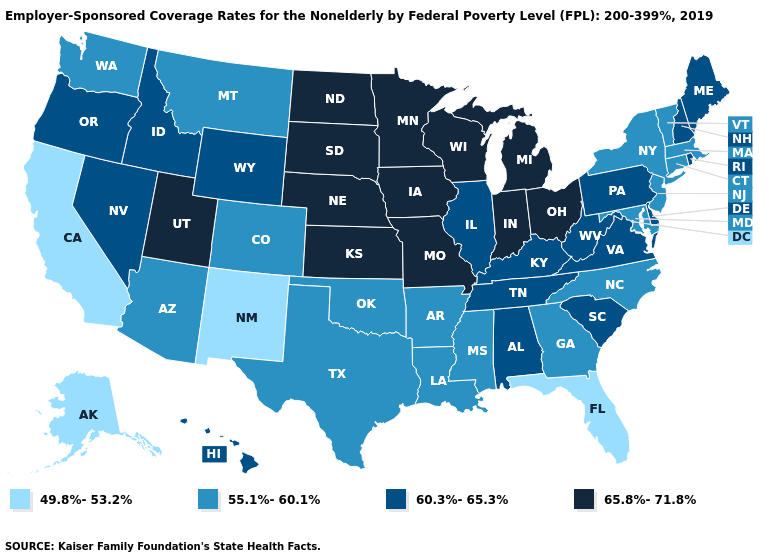Which states have the lowest value in the USA?
Concise answer only. Alaska, California, Florida, New Mexico. What is the lowest value in the USA?
Be succinct. 49.8%-53.2%. Name the states that have a value in the range 49.8%-53.2%?
Answer briefly. Alaska, California, Florida, New Mexico. Does Maine have a higher value than Wyoming?
Give a very brief answer. No. What is the value of Louisiana?
Be succinct. 55.1%-60.1%. Does Kansas have a higher value than North Dakota?
Be succinct. No. What is the lowest value in the USA?
Answer briefly. 49.8%-53.2%. Name the states that have a value in the range 55.1%-60.1%?
Answer briefly. Arizona, Arkansas, Colorado, Connecticut, Georgia, Louisiana, Maryland, Massachusetts, Mississippi, Montana, New Jersey, New York, North Carolina, Oklahoma, Texas, Vermont, Washington. What is the value of Texas?
Keep it brief. 55.1%-60.1%. Among the states that border Oklahoma , which have the lowest value?
Answer briefly. New Mexico. Does the map have missing data?
Keep it brief. No. What is the value of Michigan?
Short answer required. 65.8%-71.8%. Does North Dakota have the highest value in the USA?
Write a very short answer. Yes. What is the highest value in the USA?
Be succinct. 65.8%-71.8%. Among the states that border Delaware , does Pennsylvania have the lowest value?
Keep it brief. No. 